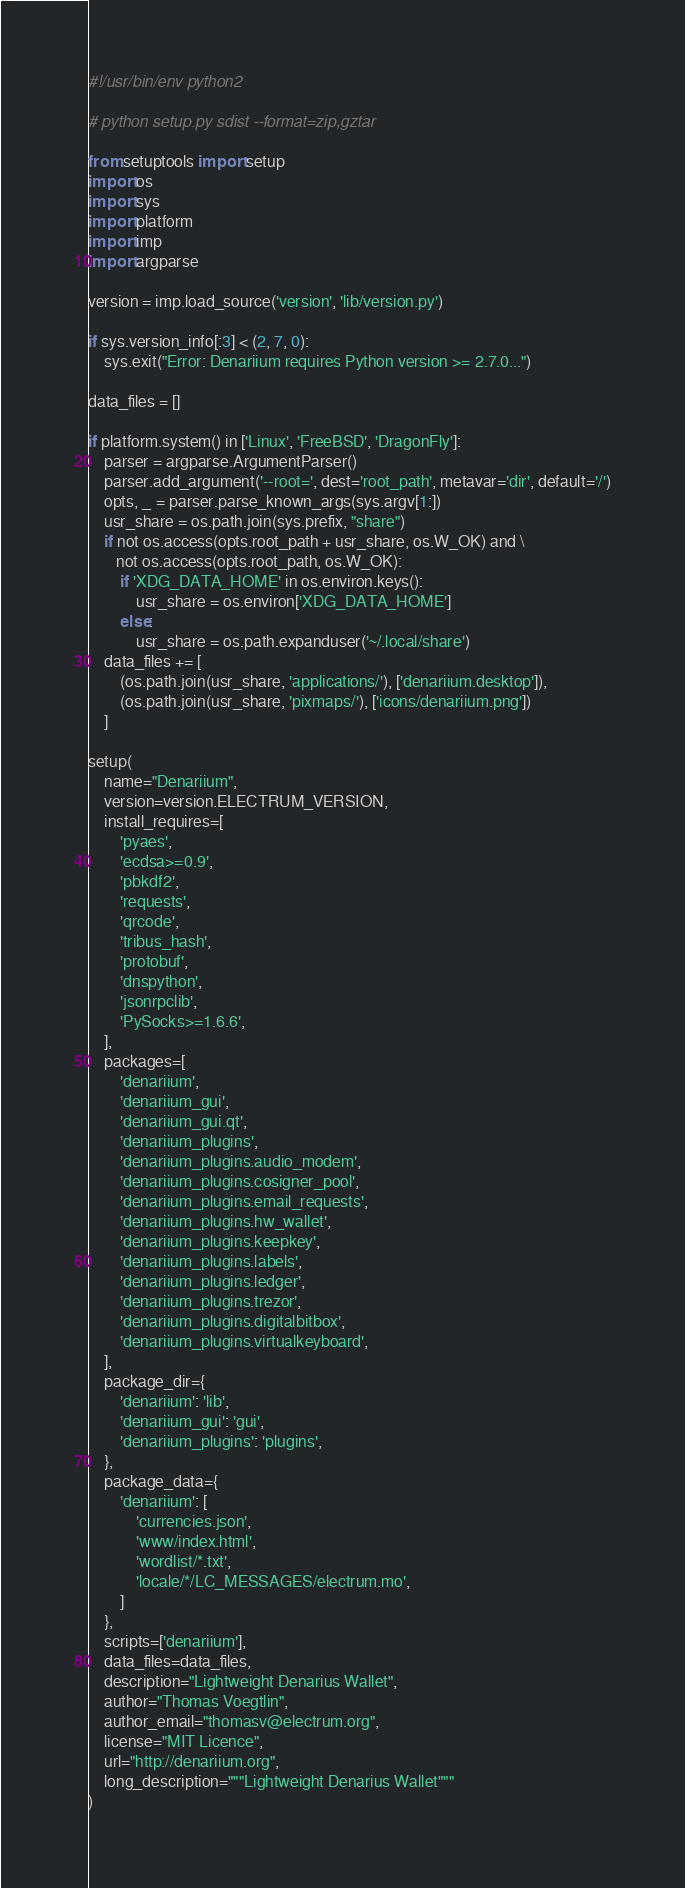Convert code to text. <code><loc_0><loc_0><loc_500><loc_500><_Python_>#!/usr/bin/env python2

# python setup.py sdist --format=zip,gztar

from setuptools import setup
import os
import sys
import platform
import imp
import argparse

version = imp.load_source('version', 'lib/version.py')

if sys.version_info[:3] < (2, 7, 0):
    sys.exit("Error: Denariium requires Python version >= 2.7.0...")

data_files = []

if platform.system() in ['Linux', 'FreeBSD', 'DragonFly']:
    parser = argparse.ArgumentParser()
    parser.add_argument('--root=', dest='root_path', metavar='dir', default='/')
    opts, _ = parser.parse_known_args(sys.argv[1:])
    usr_share = os.path.join(sys.prefix, "share")
    if not os.access(opts.root_path + usr_share, os.W_OK) and \
       not os.access(opts.root_path, os.W_OK):
        if 'XDG_DATA_HOME' in os.environ.keys():
            usr_share = os.environ['XDG_DATA_HOME']
        else:
            usr_share = os.path.expanduser('~/.local/share')
    data_files += [
        (os.path.join(usr_share, 'applications/'), ['denariium.desktop']),
        (os.path.join(usr_share, 'pixmaps/'), ['icons/denariium.png'])
    ]

setup(
    name="Denariium",
    version=version.ELECTRUM_VERSION,
    install_requires=[
        'pyaes',
        'ecdsa>=0.9',
        'pbkdf2',
        'requests',
        'qrcode',
        'tribus_hash',
        'protobuf',
        'dnspython',
        'jsonrpclib',
        'PySocks>=1.6.6',
    ],
    packages=[
        'denariium',
        'denariium_gui',
        'denariium_gui.qt',
        'denariium_plugins',
        'denariium_plugins.audio_modem',
        'denariium_plugins.cosigner_pool',
        'denariium_plugins.email_requests',
        'denariium_plugins.hw_wallet',
        'denariium_plugins.keepkey',
        'denariium_plugins.labels',
        'denariium_plugins.ledger',
        'denariium_plugins.trezor',
        'denariium_plugins.digitalbitbox',
        'denariium_plugins.virtualkeyboard',
    ],
    package_dir={
        'denariium': 'lib',
        'denariium_gui': 'gui',
        'denariium_plugins': 'plugins',
    },
    package_data={
        'denariium': [
            'currencies.json',
            'www/index.html',
            'wordlist/*.txt',
            'locale/*/LC_MESSAGES/electrum.mo',
        ]
    },
    scripts=['denariium'],
    data_files=data_files,
    description="Lightweight Denarius Wallet",
    author="Thomas Voegtlin",
    author_email="thomasv@electrum.org",
    license="MIT Licence",
    url="http://denariium.org",
    long_description="""Lightweight Denarius Wallet"""
)
</code> 